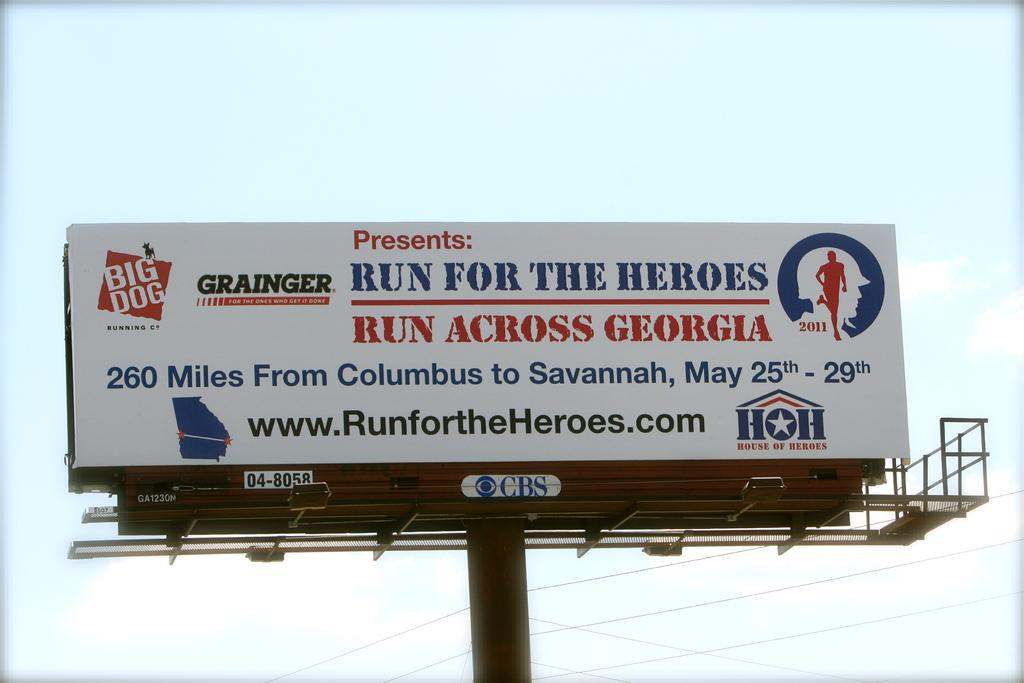What is present in the image that contains text? There is a wording in the image. Can you describe the text on the wording? There are words on the wording. What type of cloth is being used by the doctor in the image? There is no doctor or cloth present in the image; it only contains wording with text. 